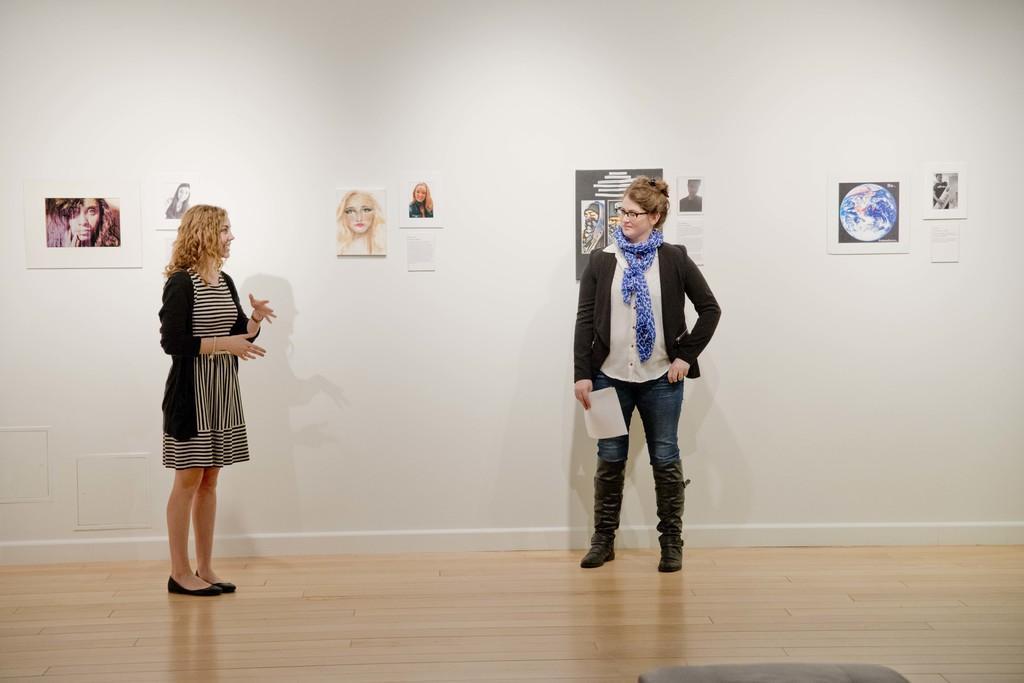How would you summarize this image in a sentence or two? In this image there are two women standing and talking with each other, behind them there are pictures of few people on the wall. 